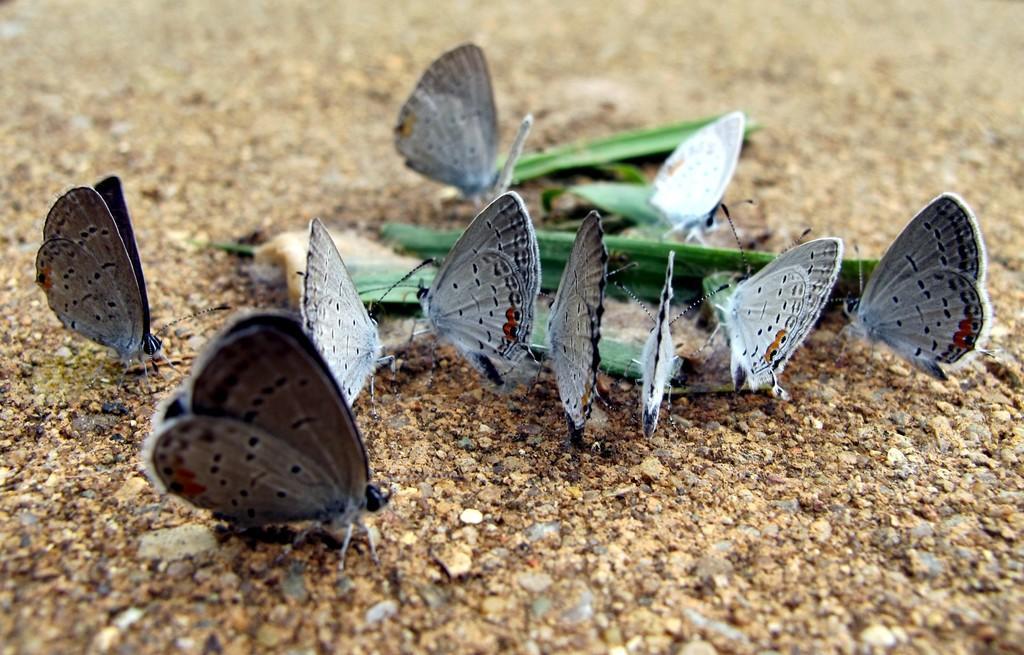Can you describe this image briefly? This image is taken outdoors. At the bottom of the image there is a ground. In the middle of the image there are many butterflies on the ground and there is a green leaf. 